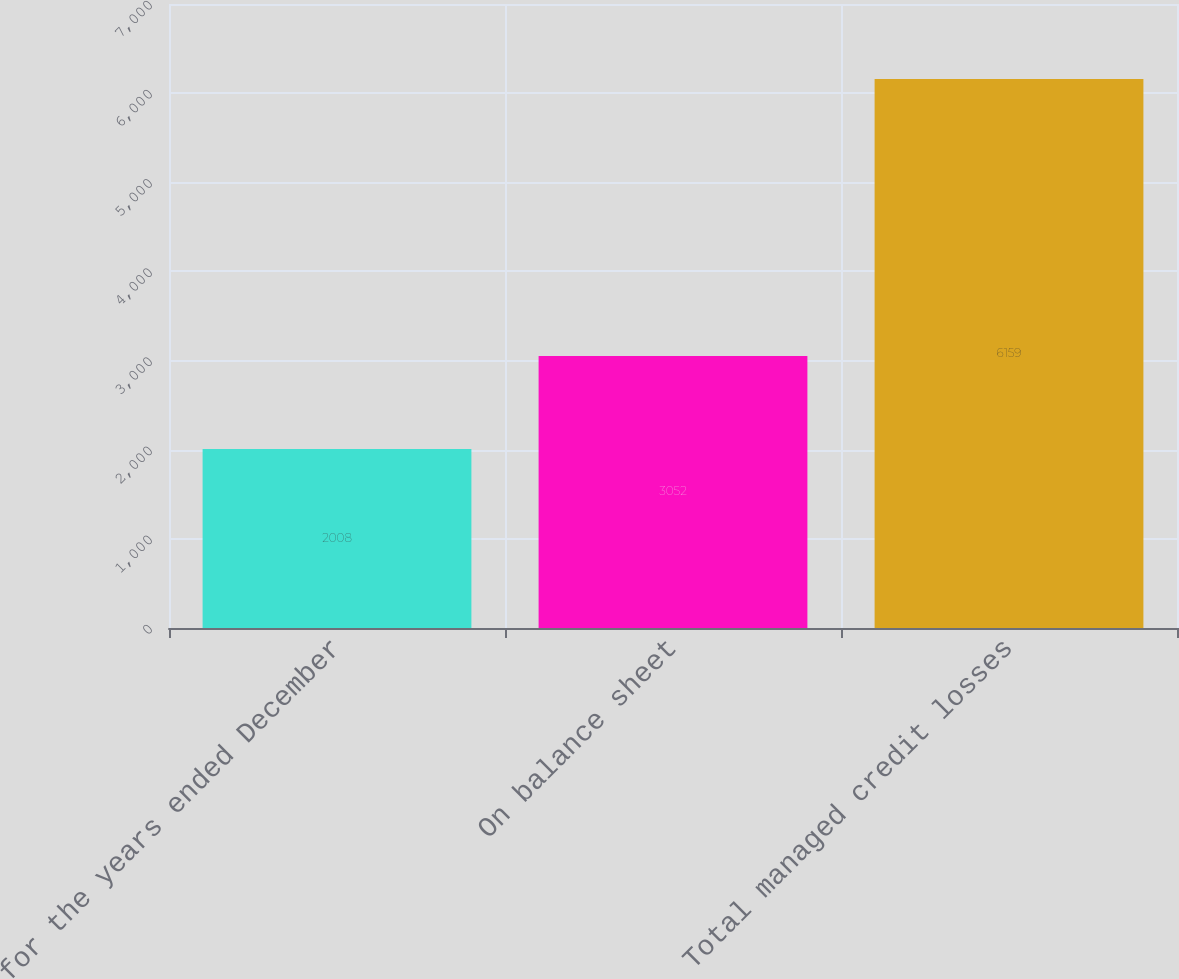Convert chart to OTSL. <chart><loc_0><loc_0><loc_500><loc_500><bar_chart><fcel>for the years ended December<fcel>On balance sheet<fcel>Total managed credit losses<nl><fcel>2008<fcel>3052<fcel>6159<nl></chart> 